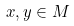Convert formula to latex. <formula><loc_0><loc_0><loc_500><loc_500>\, x , y \in M</formula> 